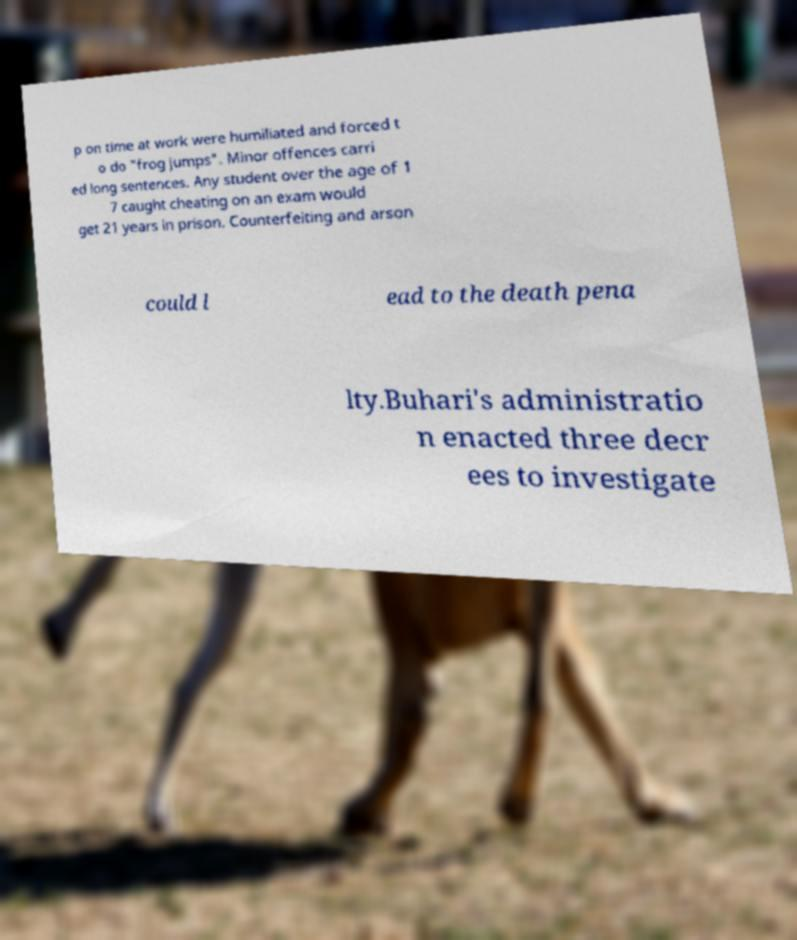Please read and relay the text visible in this image. What does it say? p on time at work were humiliated and forced t o do "frog jumps". Minor offences carri ed long sentences. Any student over the age of 1 7 caught cheating on an exam would get 21 years in prison. Counterfeiting and arson could l ead to the death pena lty.Buhari's administratio n enacted three decr ees to investigate 